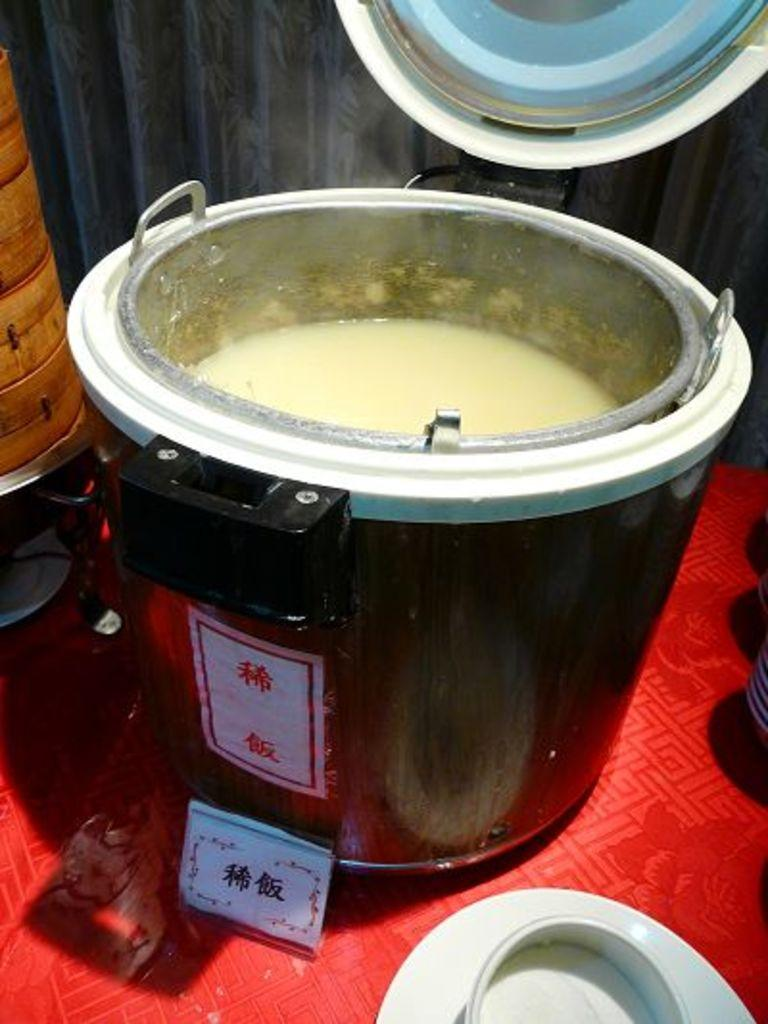What type of containers are present in the image? There are steel vessels in the image. What can be found inside the steel vessels? There is something inside the steel vessels. What other objects are placed around the steel vessels? There are other objects placed around the steel vessels. What type of apparel is being worn by the grain in the image? There is no grain or apparel present in the image. What type of throne is visible in the image? There is no throne present in the image. 